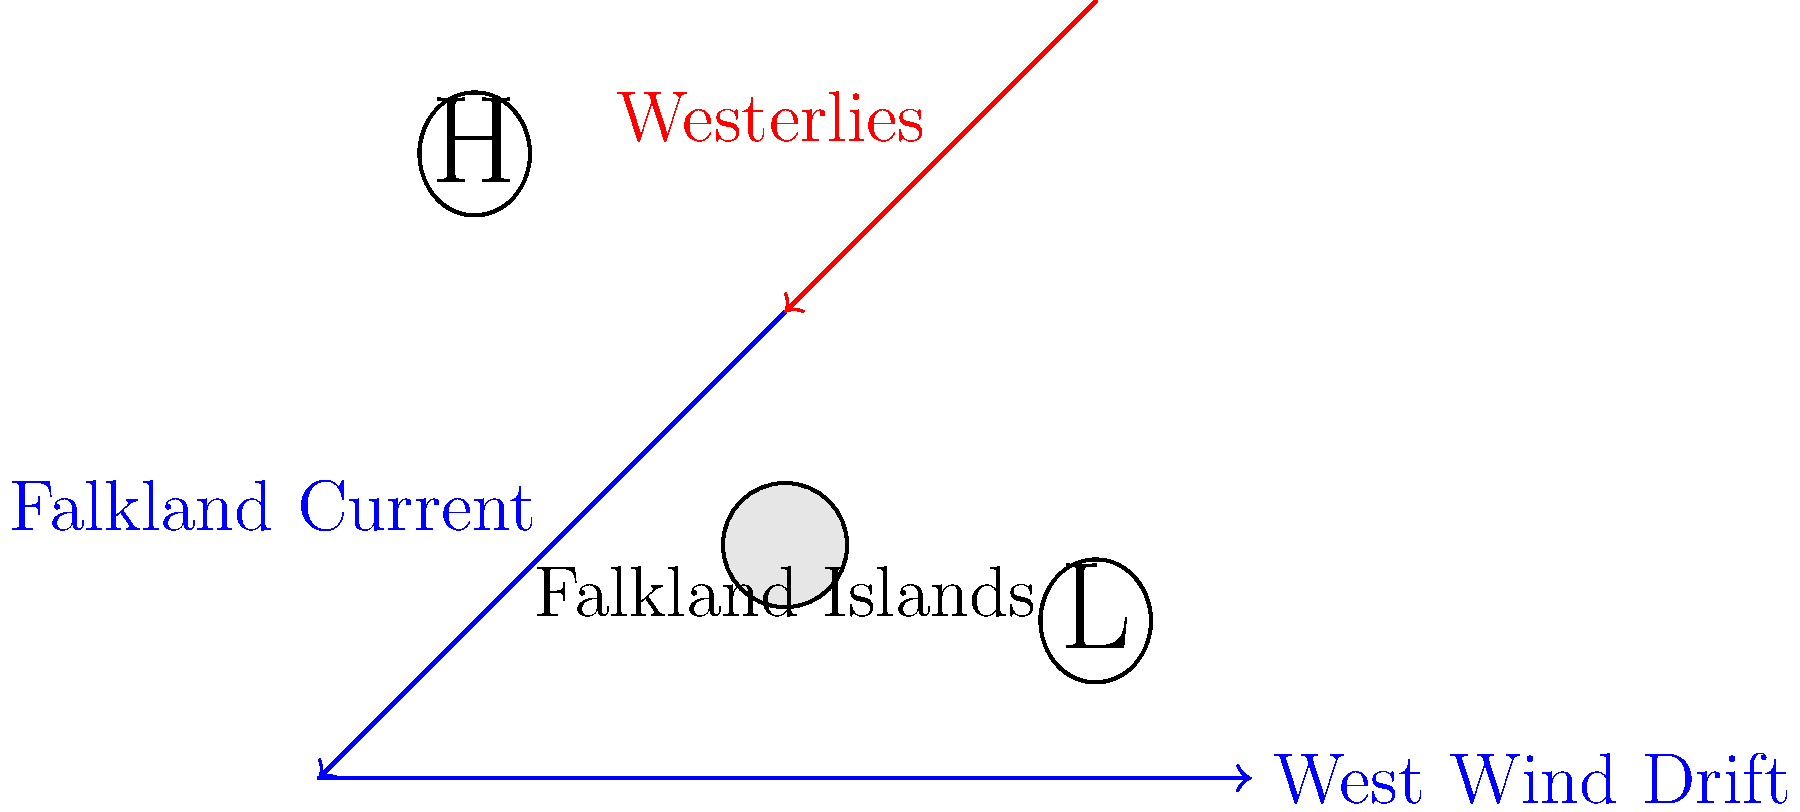Based on the diagram, which ocean current significantly influences the climate of the Falkland Islands, and how does it interact with the prevailing wind patterns in the region? To answer this question, let's analyze the diagram step-by-step:

1. Ocean currents:
   a) The West Wind Drift (or Antarctic Circumpolar Current) flows from west to east at the bottom of the diagram.
   b) The Falkland Current branches off from the West Wind Drift, flowing northward past the Falkland Islands.

2. Wind patterns:
   The Westerlies are shown blowing from west to east in the upper part of the diagram.

3. Meteorological features:
   a) A high-pressure system (\textcircled{H}) is located to the northwest of the islands.
   b) A low-pressure system (\textcircled{L}) is located to the southeast of the islands.

4. Interaction between currents and winds:
   The Falkland Current brings cold Antarctic waters northward, while the Westerlies blow from west to east across the islands.

5. Climate influence:
   The combination of the cold Falkland Current and the prevailing Westerlies creates a cool, maritime climate for the Falkland Islands.

Therefore, the Falkland Current significantly influences the climate of the Falkland Islands by bringing cold Antarctic waters northward. It interacts with the Westerlies, which blow across the islands, reinforcing the cool maritime conditions.
Answer: The Falkland Current brings cold Antarctic waters northward, interacting with the Westerlies to create a cool, maritime climate. 